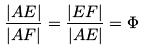Convert formula to latex. <formula><loc_0><loc_0><loc_500><loc_500>\frac { | A E | } { | A F | } = \frac { | E F | } { | A E | } = \Phi</formula> 